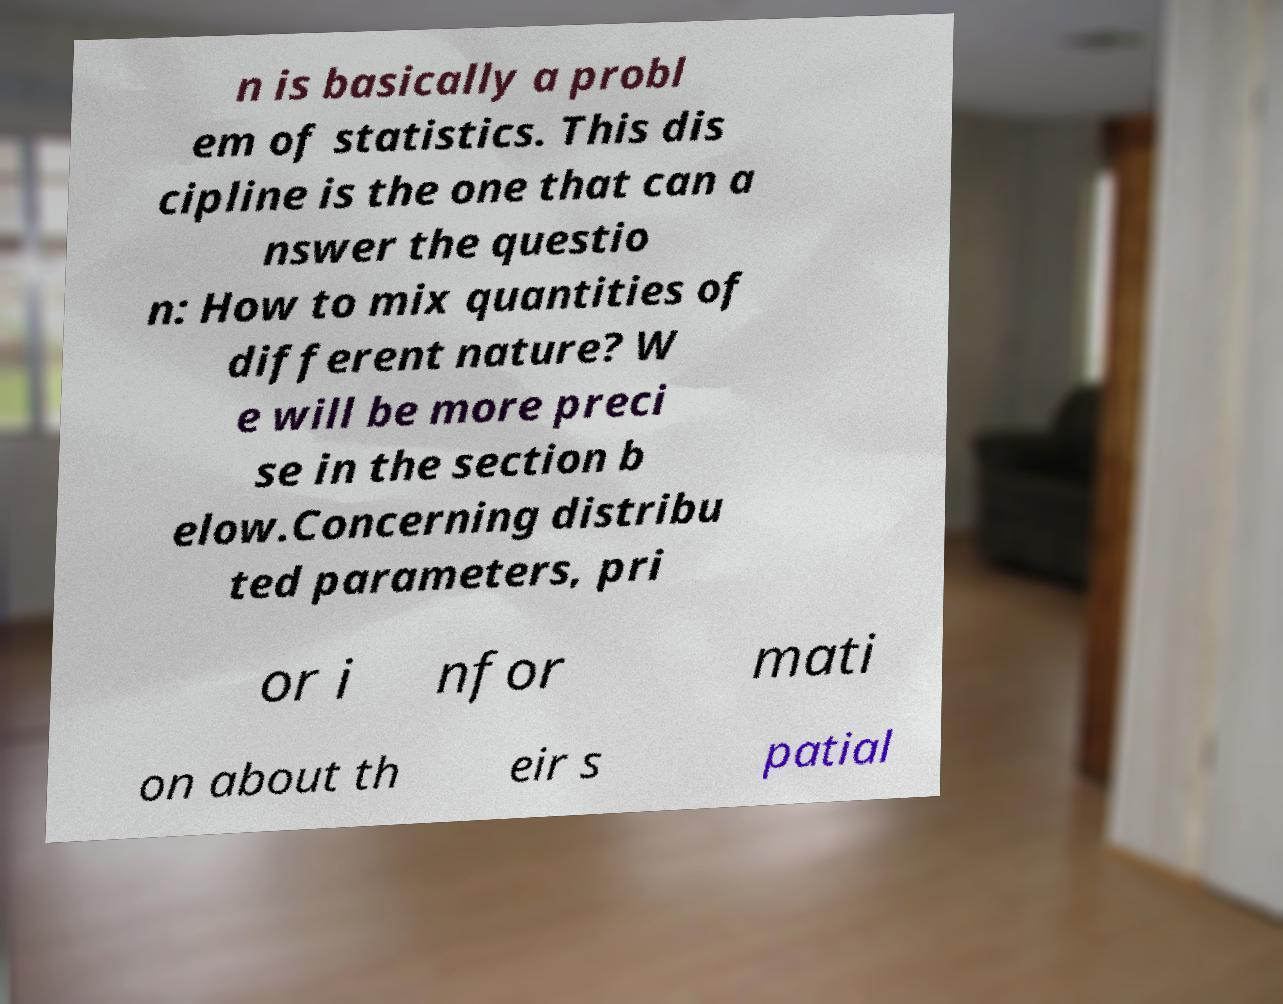Please identify and transcribe the text found in this image. n is basically a probl em of statistics. This dis cipline is the one that can a nswer the questio n: How to mix quantities of different nature? W e will be more preci se in the section b elow.Concerning distribu ted parameters, pri or i nfor mati on about th eir s patial 